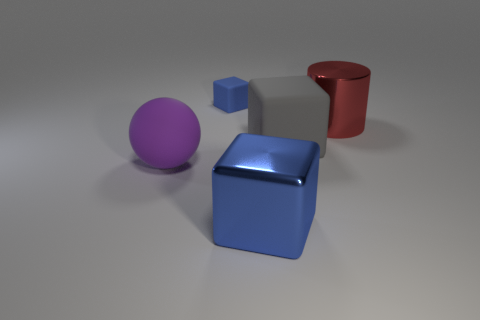Add 4 red metal cylinders. How many objects exist? 9 Subtract all balls. How many objects are left? 4 Subtract 1 red cylinders. How many objects are left? 4 Subtract all large balls. Subtract all red metallic objects. How many objects are left? 3 Add 2 gray rubber cubes. How many gray rubber cubes are left? 3 Add 3 tiny blue matte things. How many tiny blue matte things exist? 4 